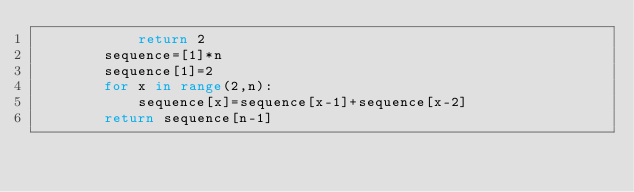Convert code to text. <code><loc_0><loc_0><loc_500><loc_500><_Python_>            return 2
        sequence=[1]*n
        sequence[1]=2
        for x in range(2,n):
            sequence[x]=sequence[x-1]+sequence[x-2]
        return sequence[n-1]</code> 